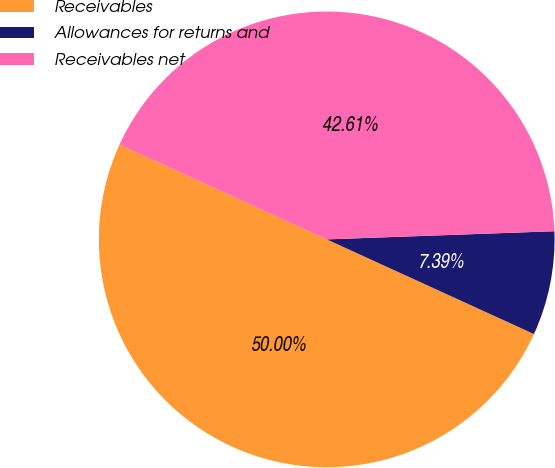<chart> <loc_0><loc_0><loc_500><loc_500><pie_chart><fcel>Receivables<fcel>Allowances for returns and<fcel>Receivables net<nl><fcel>50.0%<fcel>7.39%<fcel>42.61%<nl></chart> 